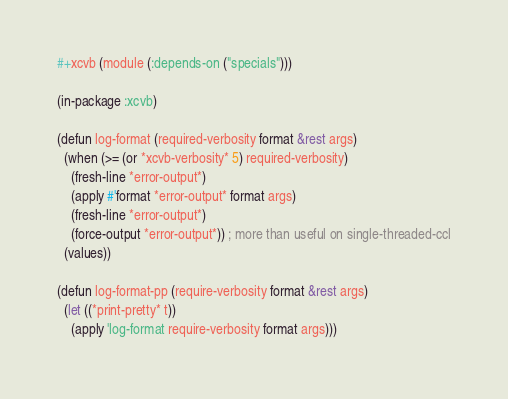<code> <loc_0><loc_0><loc_500><loc_500><_Lisp_>#+xcvb (module (:depends-on ("specials")))

(in-package :xcvb)

(defun log-format (required-verbosity format &rest args)
  (when (>= (or *xcvb-verbosity* 5) required-verbosity)
    (fresh-line *error-output*)
    (apply #'format *error-output* format args)
    (fresh-line *error-output*)
    (force-output *error-output*)) ; more than useful on single-threaded-ccl
  (values))

(defun log-format-pp (require-verbosity format &rest args)
  (let ((*print-pretty* t))
    (apply 'log-format require-verbosity format args)))
</code> 